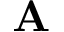<formula> <loc_0><loc_0><loc_500><loc_500>A</formula> 